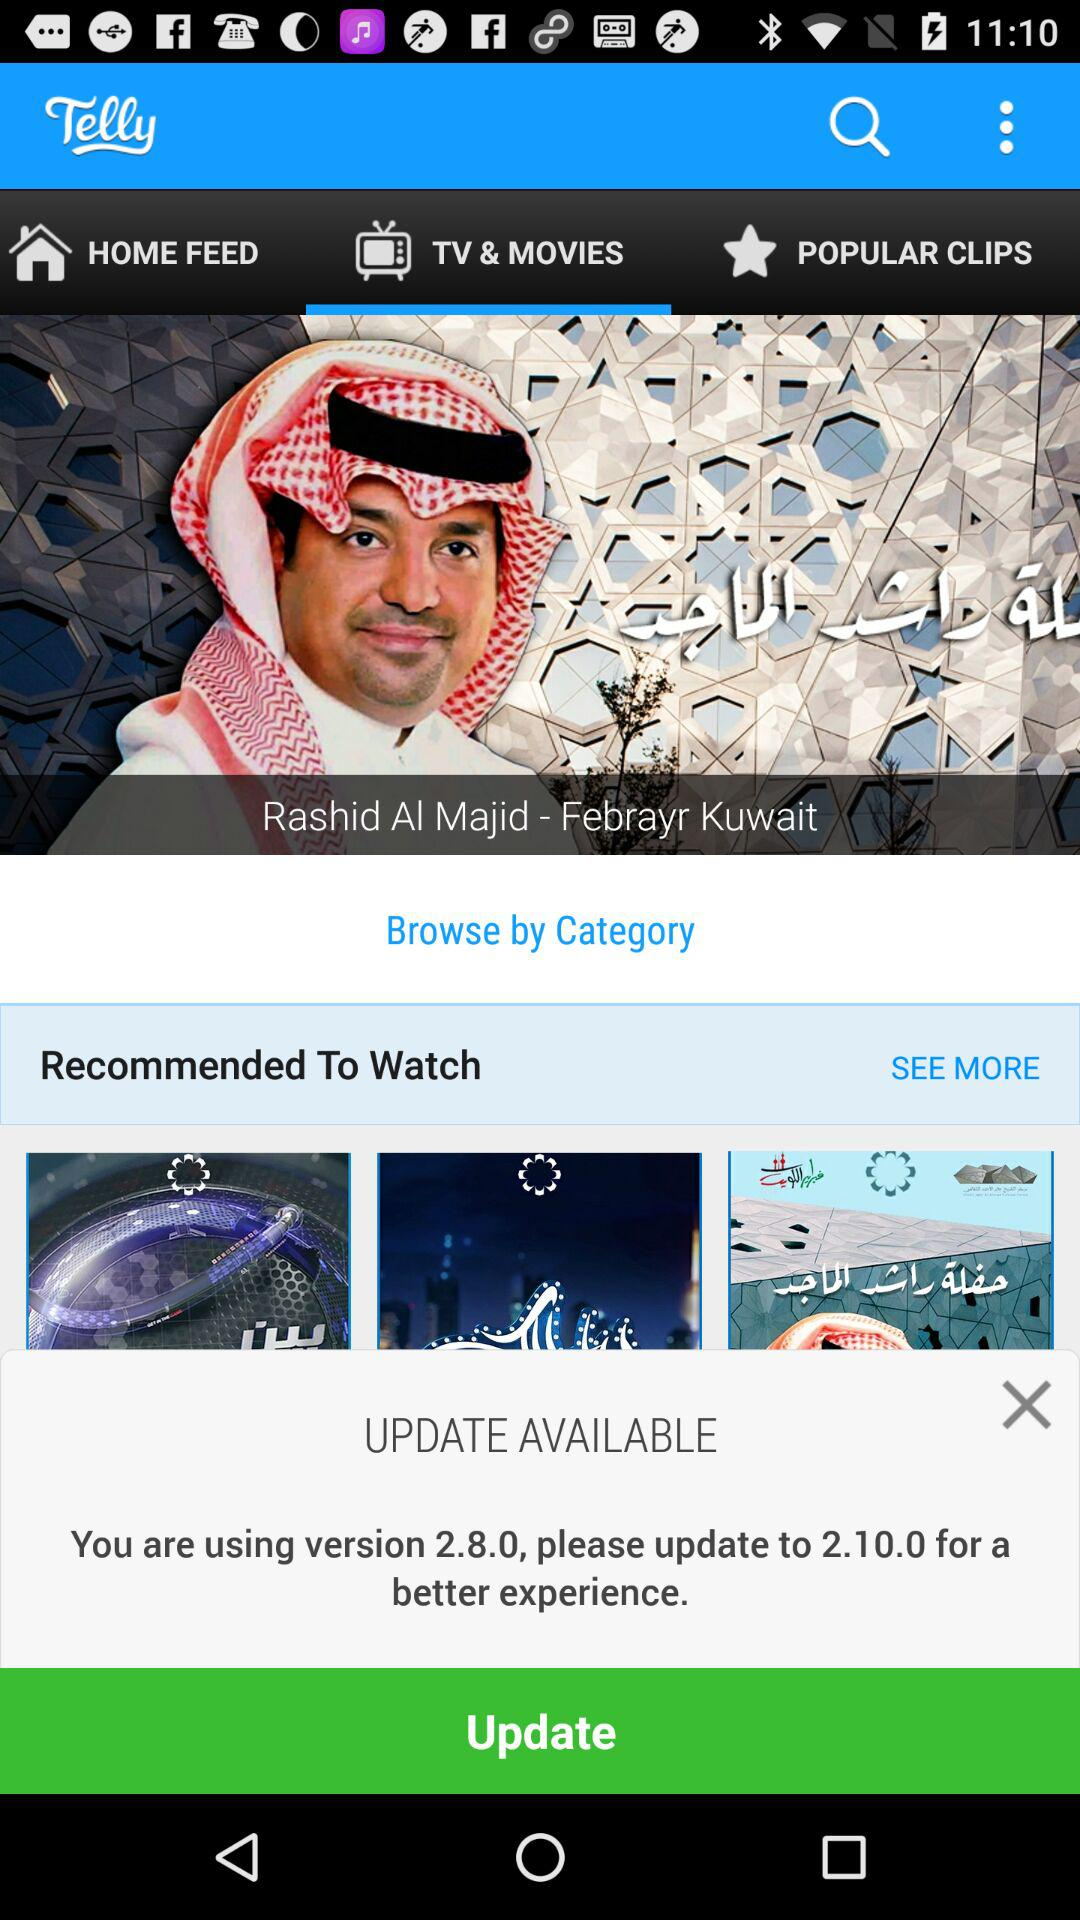What version can the application be updated to? The application can be updated to version 2.10.0. 